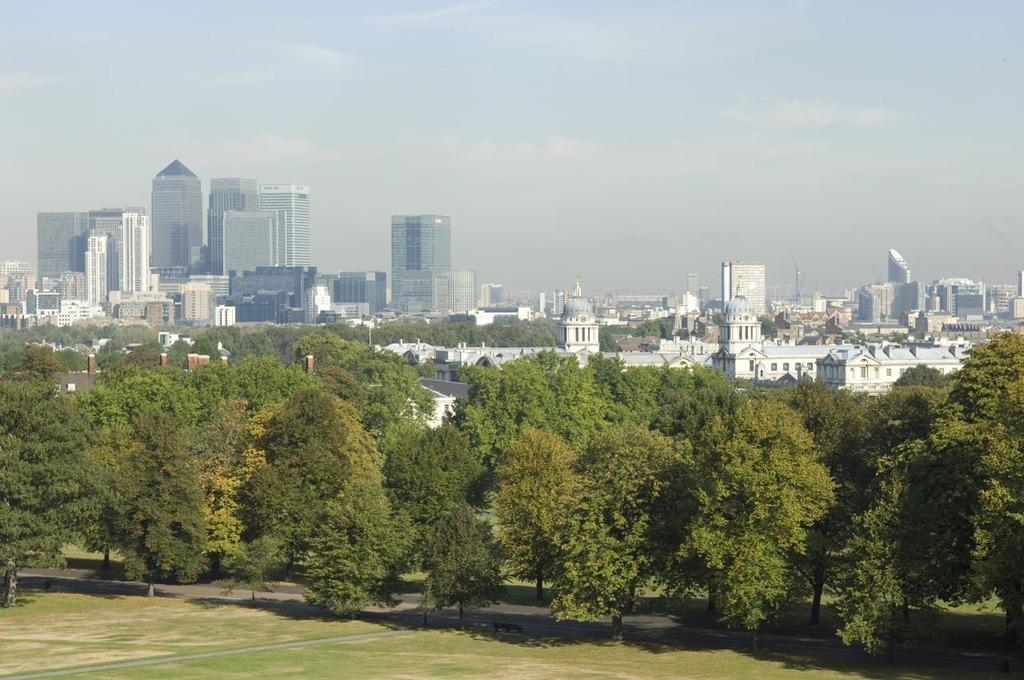What type of vegetation is present on the ground in the front of the image? There is grass on the ground in the front of the image. What can be seen in the center of the image? There are trees in the center of the image. What type of structures are visible in the background of the image? There are buildings in the background of the image. What is the condition of the sky in the image? The sky is cloudy in the image. What color is the gold scarf that the dog is wearing in the image? There is no dog, scarf, or gold in the image. The image features grass, trees, buildings, and a cloudy sky. 